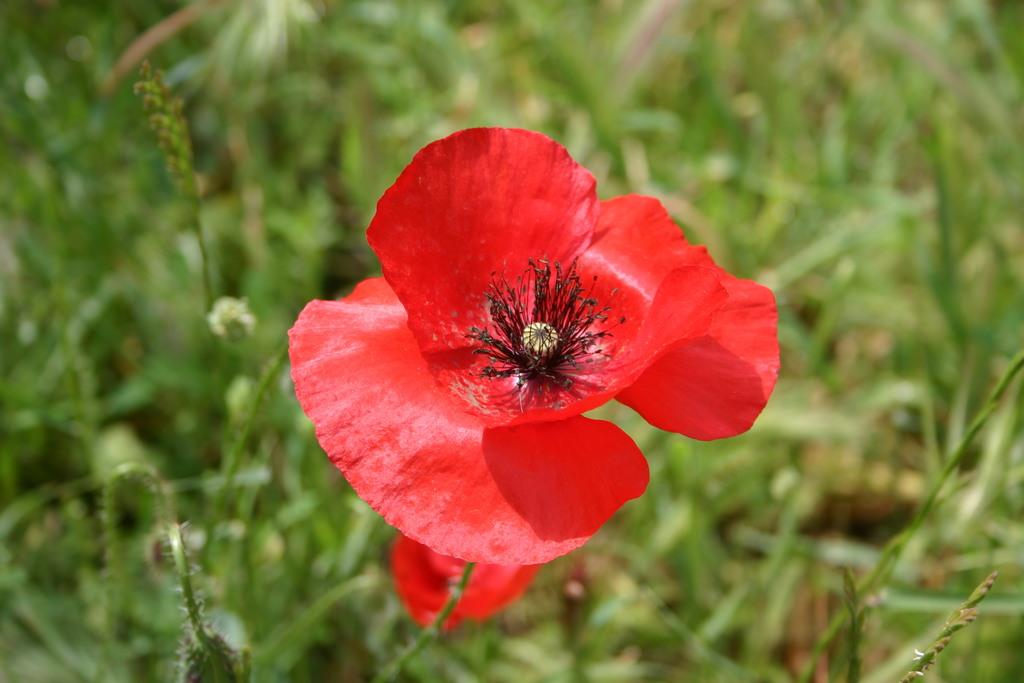What type of flower is in the image? There is a red color flower in the image. What is the flower a part of? The flower belongs to a plant. Can you describe the background of the image? The background of the image is blurred. What type of soap is used to clean the flower in the image? There is no soap present in the image, and the flower is not being cleaned. 